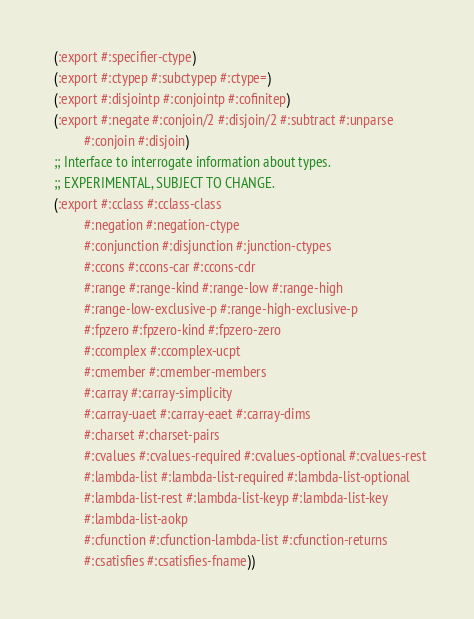Convert code to text. <code><loc_0><loc_0><loc_500><loc_500><_Lisp_>  (:export #:specifier-ctype)
  (:export #:ctypep #:subctypep #:ctype=)
  (:export #:disjointp #:conjointp #:cofinitep)
  (:export #:negate #:conjoin/2 #:disjoin/2 #:subtract #:unparse
           #:conjoin #:disjoin)
  ;; Interface to interrogate information about types.
  ;; EXPERIMENTAL, SUBJECT TO CHANGE.
  (:export #:cclass #:cclass-class
           #:negation #:negation-ctype
           #:conjunction #:disjunction #:junction-ctypes
           #:ccons #:ccons-car #:ccons-cdr
           #:range #:range-kind #:range-low #:range-high
           #:range-low-exclusive-p #:range-high-exclusive-p
           #:fpzero #:fpzero-kind #:fpzero-zero
           #:ccomplex #:ccomplex-ucpt
           #:cmember #:cmember-members
           #:carray #:carray-simplicity
           #:carray-uaet #:carray-eaet #:carray-dims
           #:charset #:charset-pairs
           #:cvalues #:cvalues-required #:cvalues-optional #:cvalues-rest
           #:lambda-list #:lambda-list-required #:lambda-list-optional
           #:lambda-list-rest #:lambda-list-keyp #:lambda-list-key
           #:lambda-list-aokp
           #:cfunction #:cfunction-lambda-list #:cfunction-returns
           #:csatisfies #:csatisfies-fname))
</code> 